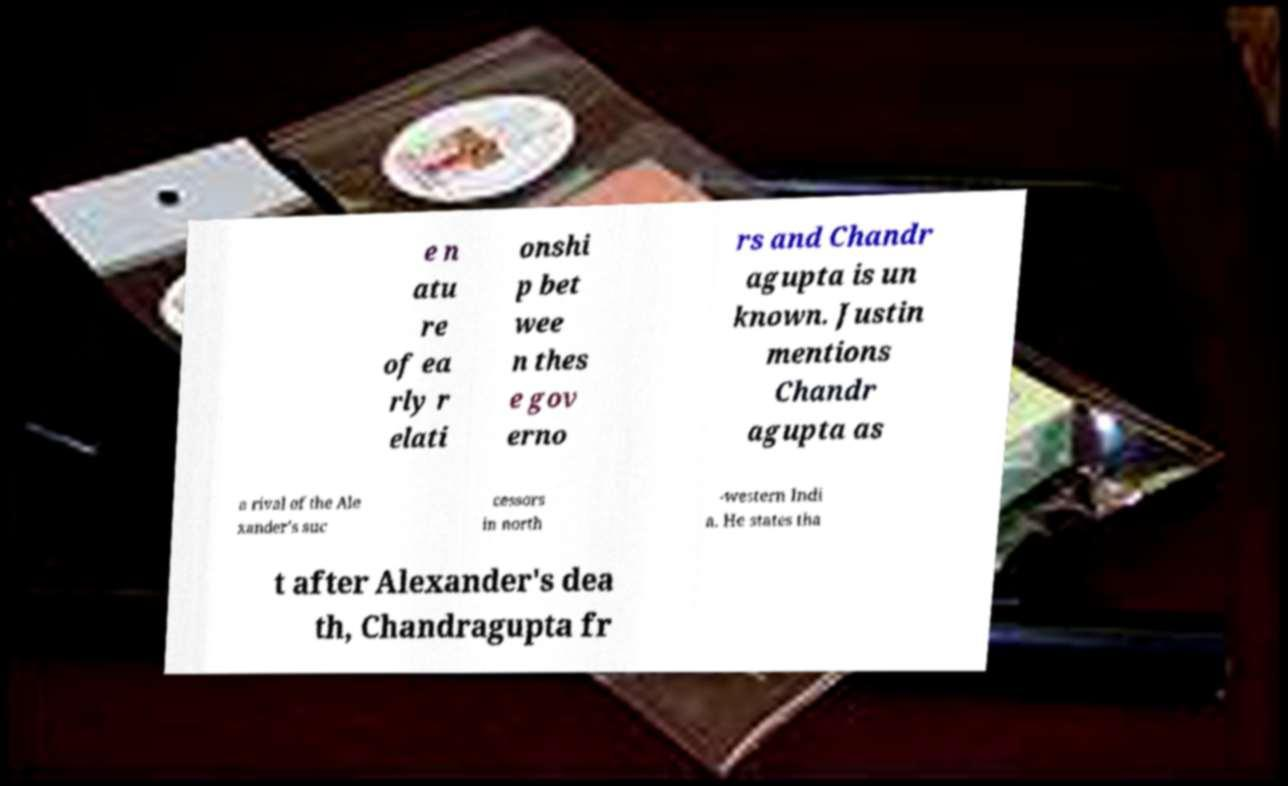Please identify and transcribe the text found in this image. e n atu re of ea rly r elati onshi p bet wee n thes e gov erno rs and Chandr agupta is un known. Justin mentions Chandr agupta as a rival of the Ale xander's suc cessors in north -western Indi a. He states tha t after Alexander's dea th, Chandragupta fr 